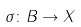<formula> <loc_0><loc_0><loc_500><loc_500>\sigma \colon B \rightarrow X</formula> 